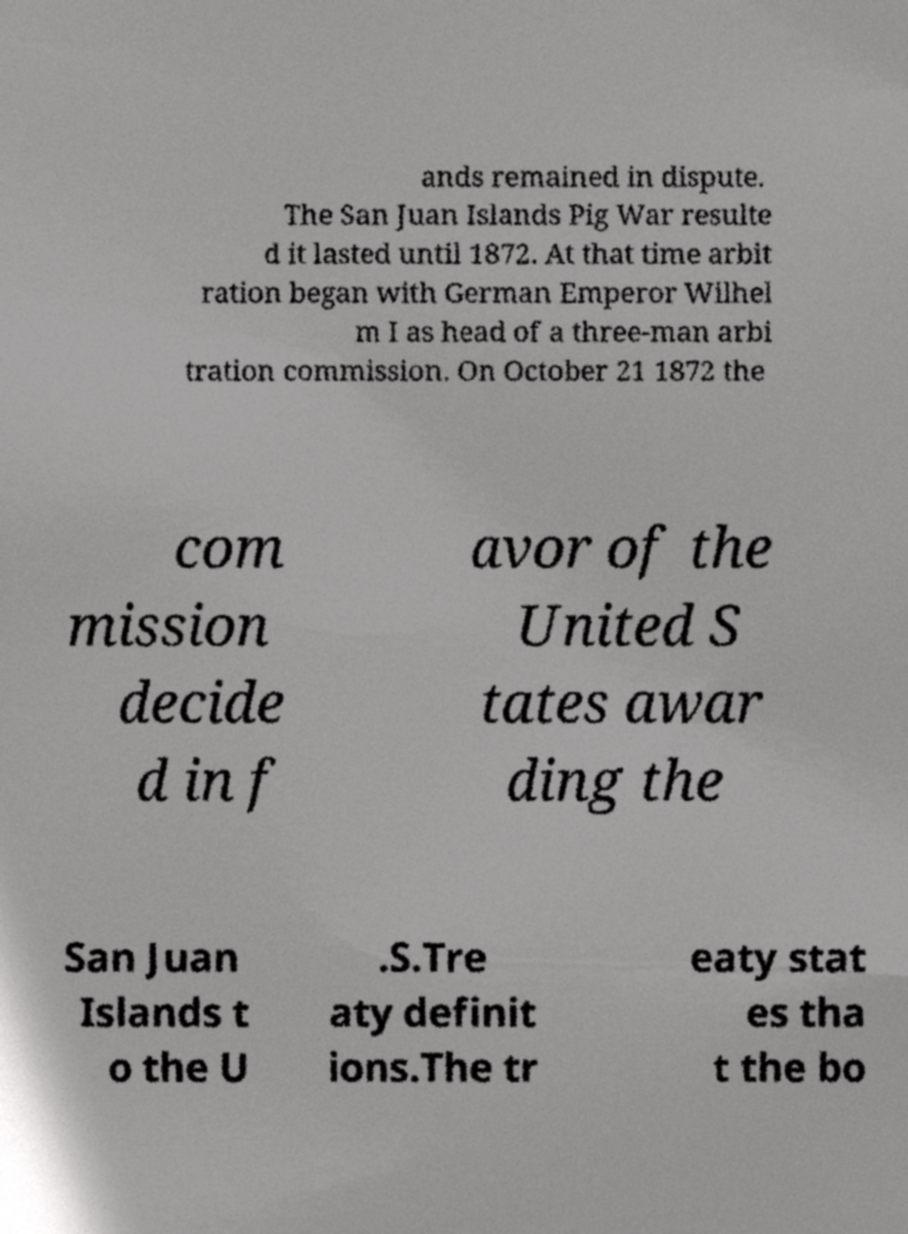Please identify and transcribe the text found in this image. ands remained in dispute. The San Juan Islands Pig War resulte d it lasted until 1872. At that time arbit ration began with German Emperor Wilhel m I as head of a three-man arbi tration commission. On October 21 1872 the com mission decide d in f avor of the United S tates awar ding the San Juan Islands t o the U .S.Tre aty definit ions.The tr eaty stat es tha t the bo 